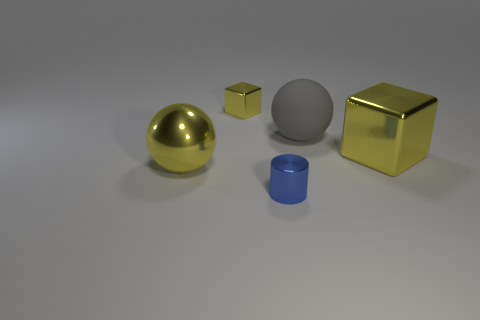Could you describe the lighting in the scene? Certainly. The lighting in the scene casts subtle shadows to the right of the objects, indicating a light source to the left. The soft nature of the shadows suggests a diffused light source, which contributes to the overall muted ambiance. The reflective surfaces of the sphere and the cube on the right suggest a relatively strong light source, as indicated by the bright highlights and the contrast they create with the shadows. 